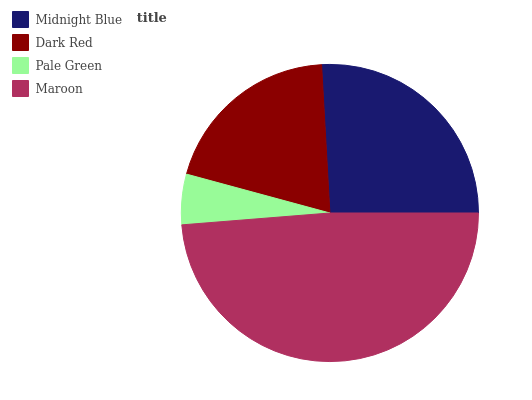Is Pale Green the minimum?
Answer yes or no. Yes. Is Maroon the maximum?
Answer yes or no. Yes. Is Dark Red the minimum?
Answer yes or no. No. Is Dark Red the maximum?
Answer yes or no. No. Is Midnight Blue greater than Dark Red?
Answer yes or no. Yes. Is Dark Red less than Midnight Blue?
Answer yes or no. Yes. Is Dark Red greater than Midnight Blue?
Answer yes or no. No. Is Midnight Blue less than Dark Red?
Answer yes or no. No. Is Midnight Blue the high median?
Answer yes or no. Yes. Is Dark Red the low median?
Answer yes or no. Yes. Is Dark Red the high median?
Answer yes or no. No. Is Maroon the low median?
Answer yes or no. No. 